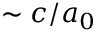Convert formula to latex. <formula><loc_0><loc_0><loc_500><loc_500>\sim c / a _ { 0 }</formula> 